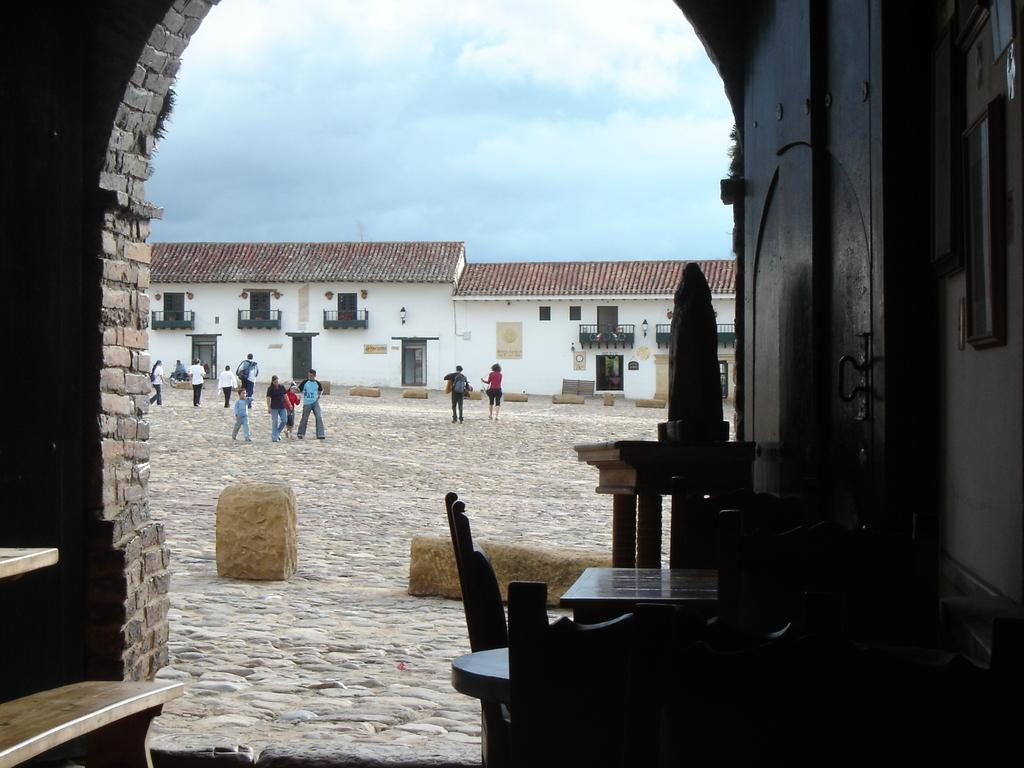What type of structures can be seen in the image? There are houses in the image. What features do the houses have? The houses have windows and doors. Can you describe the people visible in the image? There are people visible in the image. What type of terrain is present in the image? Sand is present in the image. What is visible at the top of the image? The sky is visible at the top of the image. Can you tell me how many actors are performing on the hill in the image? There is no hill or actors present in the image. What type of pan is being used by the people in the image? There is no pan visible in the image; the people are not engaged in any cooking or food preparation activities. 